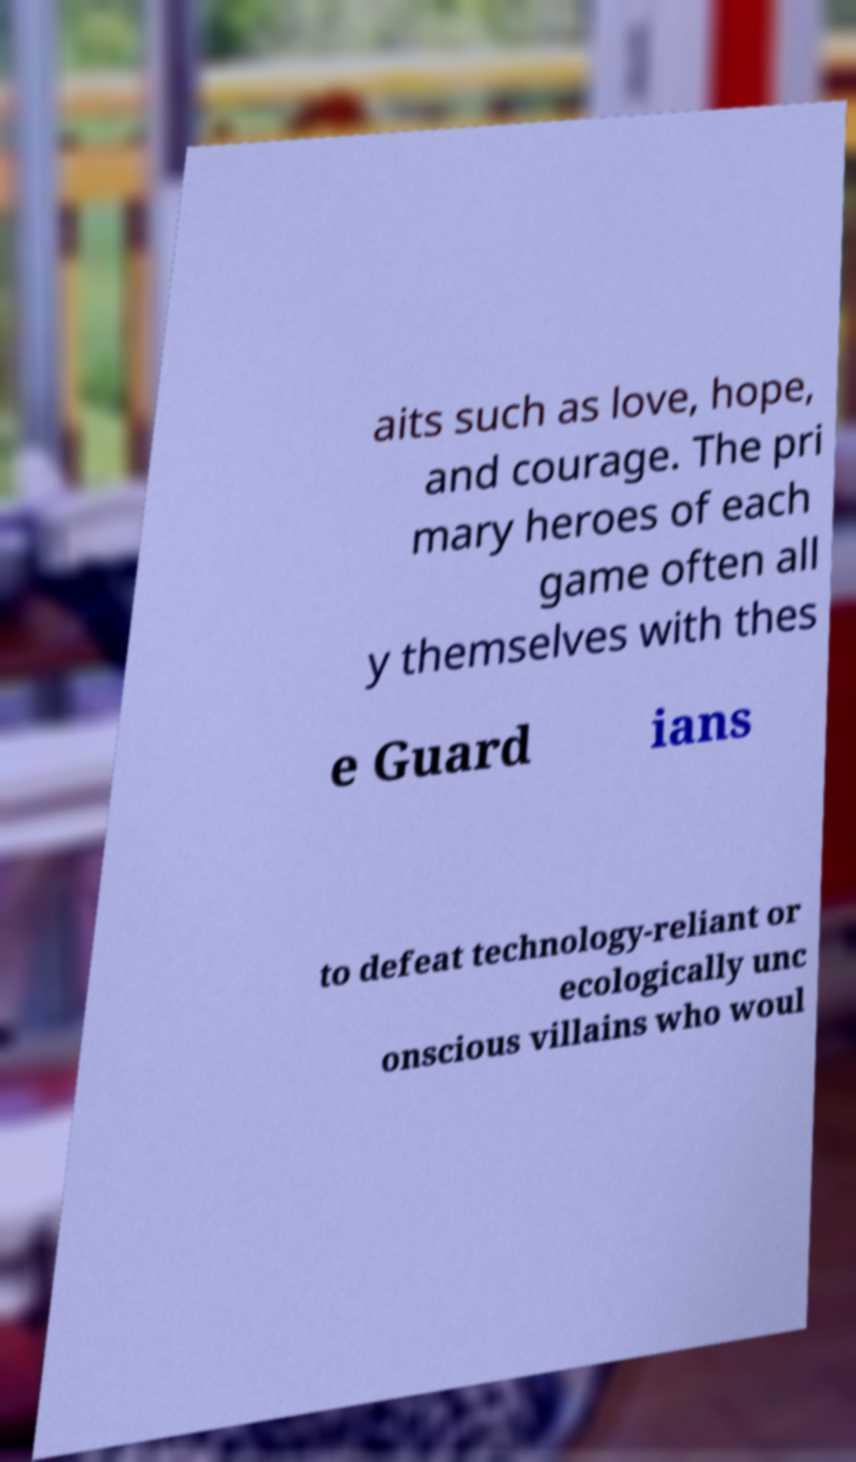Can you accurately transcribe the text from the provided image for me? aits such as love, hope, and courage. The pri mary heroes of each game often all y themselves with thes e Guard ians to defeat technology-reliant or ecologically unc onscious villains who woul 